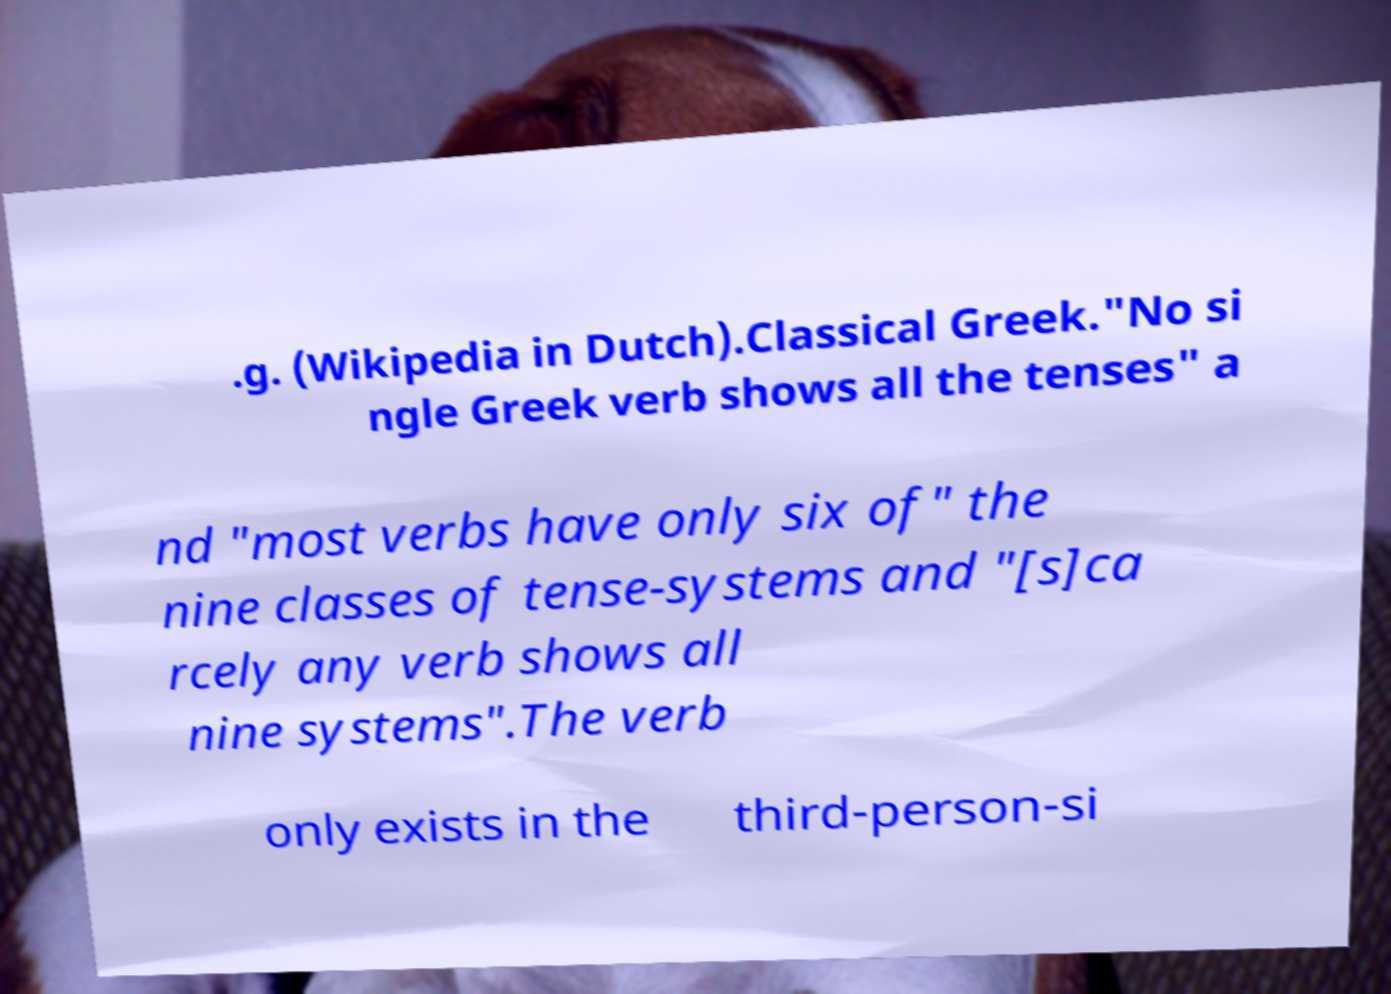Can you accurately transcribe the text from the provided image for me? .g. (Wikipedia in Dutch).Classical Greek."No si ngle Greek verb shows all the tenses" a nd "most verbs have only six of" the nine classes of tense-systems and "[s]ca rcely any verb shows all nine systems".The verb only exists in the third-person-si 